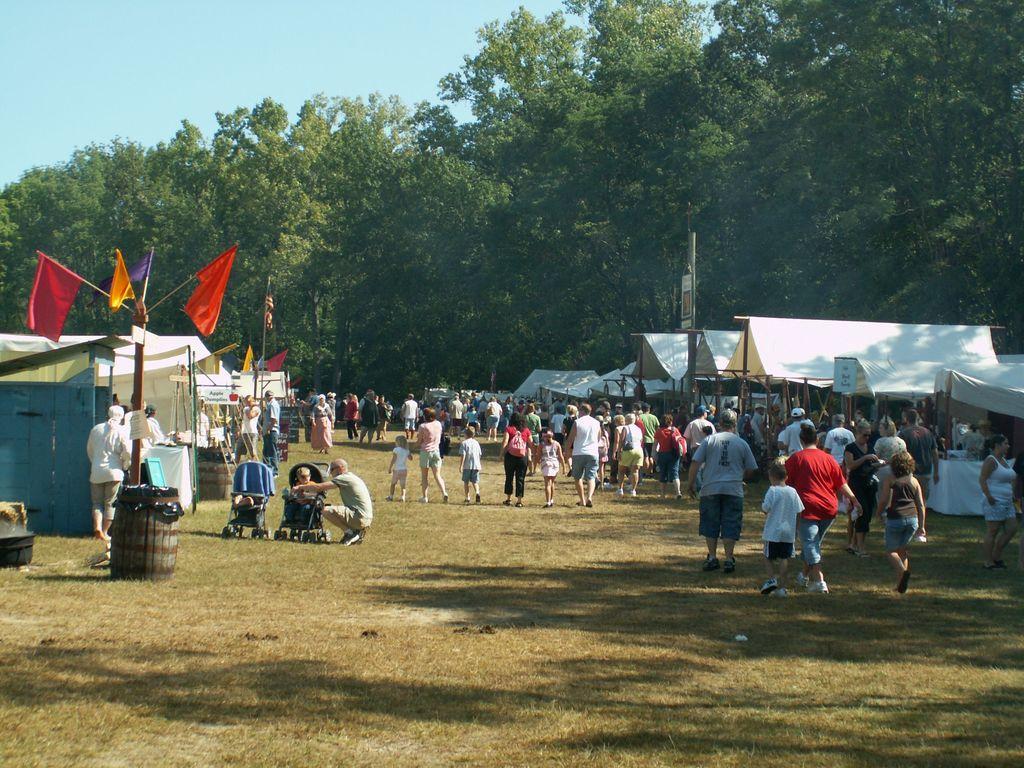How would you summarize this image in a sentence or two? In this image we can see these people are walking on the ground, here we can see barrels, baby chairs, tents, boards, flags, trees and the sky in the background. 